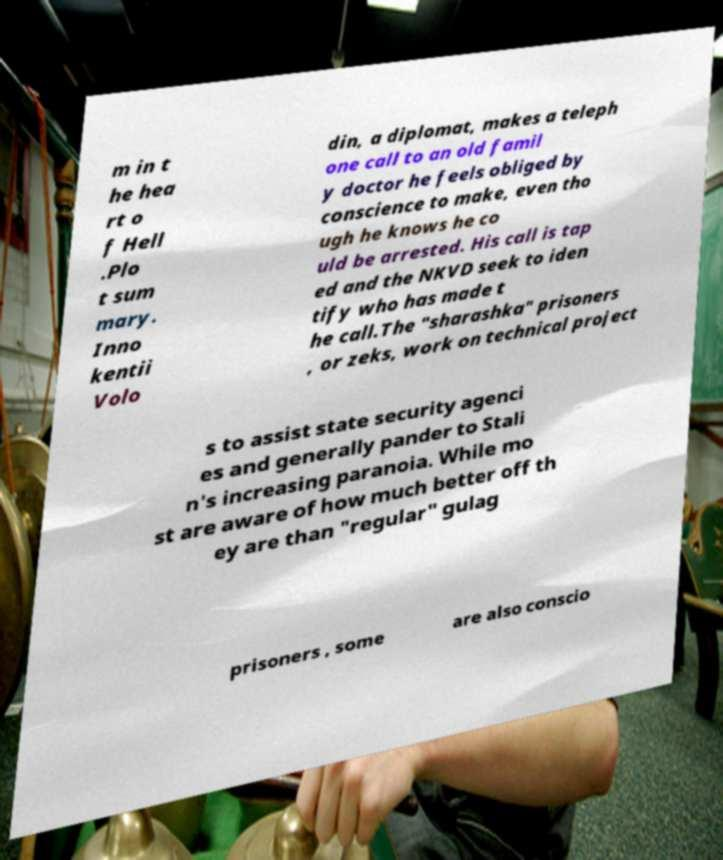Can you read and provide the text displayed in the image?This photo seems to have some interesting text. Can you extract and type it out for me? m in t he hea rt o f Hell .Plo t sum mary. Inno kentii Volo din, a diplomat, makes a teleph one call to an old famil y doctor he feels obliged by conscience to make, even tho ugh he knows he co uld be arrested. His call is tap ed and the NKVD seek to iden tify who has made t he call.The "sharashka" prisoners , or zeks, work on technical project s to assist state security agenci es and generally pander to Stali n's increasing paranoia. While mo st are aware of how much better off th ey are than "regular" gulag prisoners , some are also conscio 